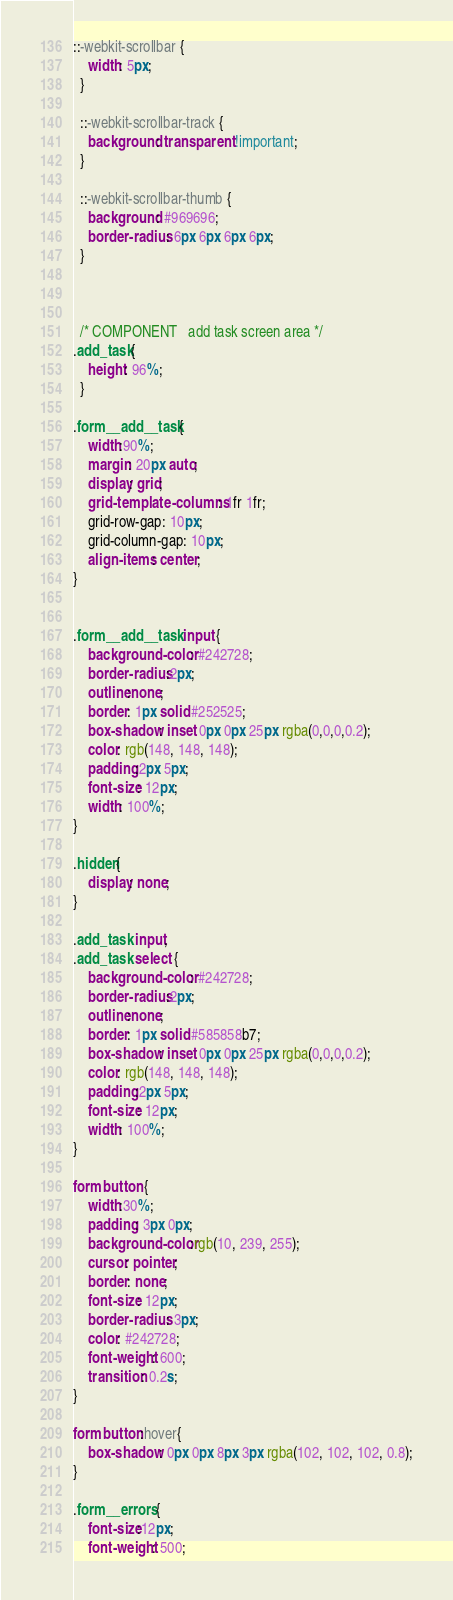<code> <loc_0><loc_0><loc_500><loc_500><_CSS_>::-webkit-scrollbar {
    width: 5px;
  }

  ::-webkit-scrollbar-track {
    background: transparent !important;
  }
  
  ::-webkit-scrollbar-thumb {
    background: #969696;
    border-radius: 6px 6px 6px 6px;
  }



  /* COMPONENT   add task screen area */
.add_task{
    height: 96%;
  }

.form__add__task{
    width:90%;
    margin: 20px auto;
    display: grid;
    grid-template-columns: 1fr 1fr;
    grid-row-gap: 10px;
    grid-column-gap: 10px;
    align-items: center;
}


.form__add__task input {
    background-color: #242728;
    border-radius:2px;
    outline:none;
    border: 1px solid #252525;
    box-shadow: inset 0px 0px 25px rgba(0,0,0,0.2);
    color: rgb(148, 148, 148); 
    padding:2px 5px;
    font-size: 12px;
    width: 100%;
}

.hidden{
    display: none;
}

.add_task input,
.add_task select {
    background-color: #242728;
    border-radius:2px;
    outline:none;
    border: 1px solid #585858b7;
    box-shadow: inset 0px 0px 25px rgba(0,0,0,0.2);
    color: rgb(148, 148, 148); 
    padding:2px 5px;
    font-size: 12px;
    width: 100%;
}

form button {
    width:30%;
    padding: 3px 0px;
    background-color:rgb(10, 239, 255); 
    cursor: pointer;
    border: none;
    font-size: 12px;
    border-radius: 3px;
    color: #242728;
    font-weight: 600;
    transition: 0.2s;
}

form button:hover{
    box-shadow: 0px 0px 8px 3px rgba(102, 102, 102, 0.8);
}

.form__errors {
    font-size:12px;
    font-weight: 500;</code> 